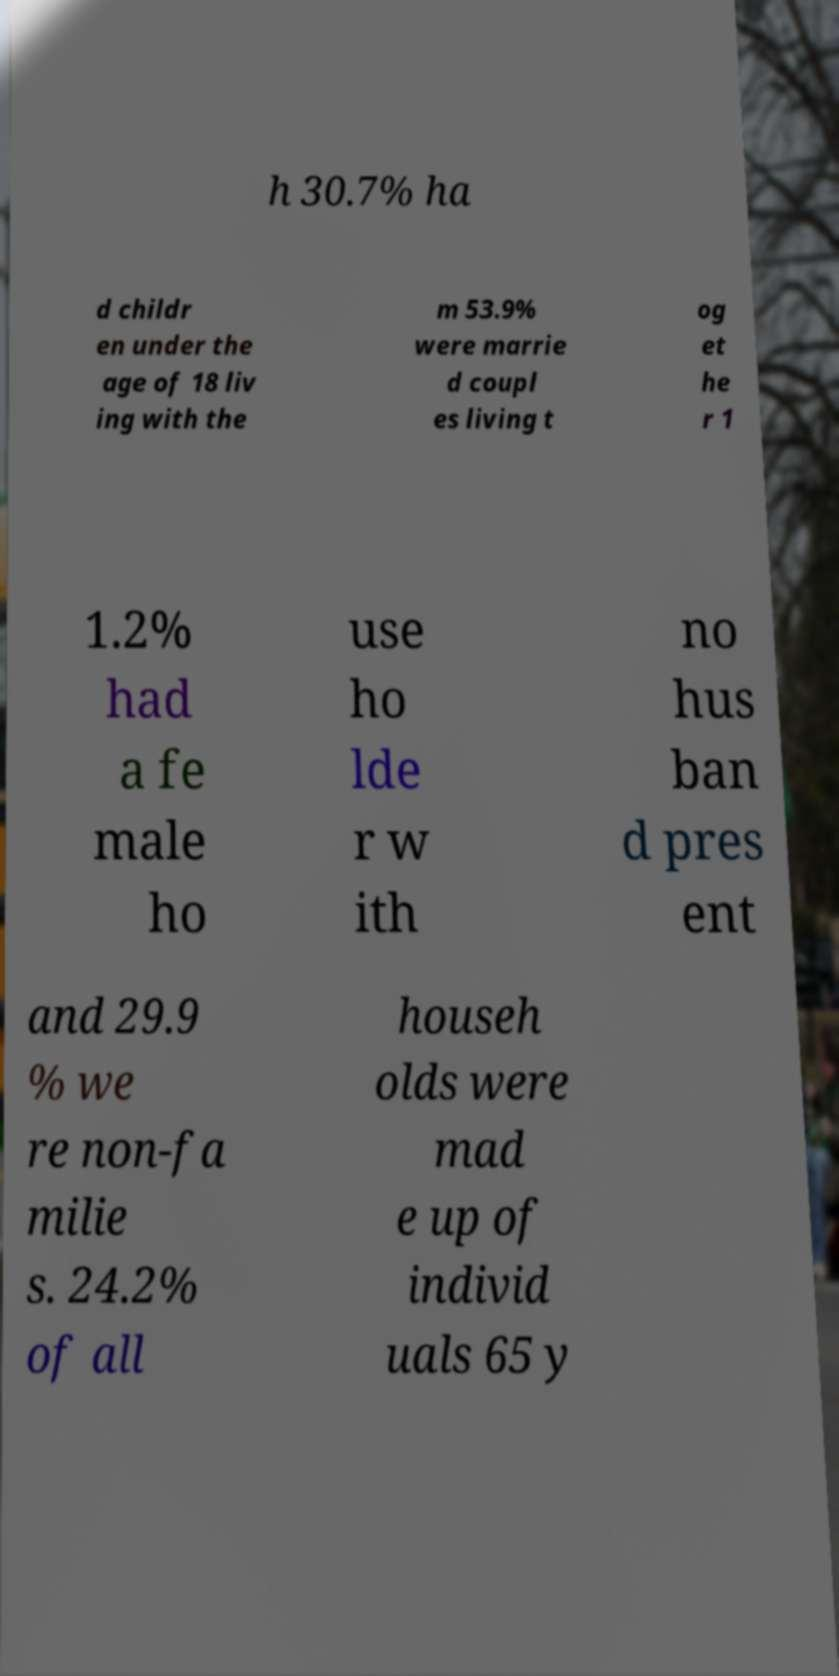Could you assist in decoding the text presented in this image and type it out clearly? h 30.7% ha d childr en under the age of 18 liv ing with the m 53.9% were marrie d coupl es living t og et he r 1 1.2% had a fe male ho use ho lde r w ith no hus ban d pres ent and 29.9 % we re non-fa milie s. 24.2% of all househ olds were mad e up of individ uals 65 y 